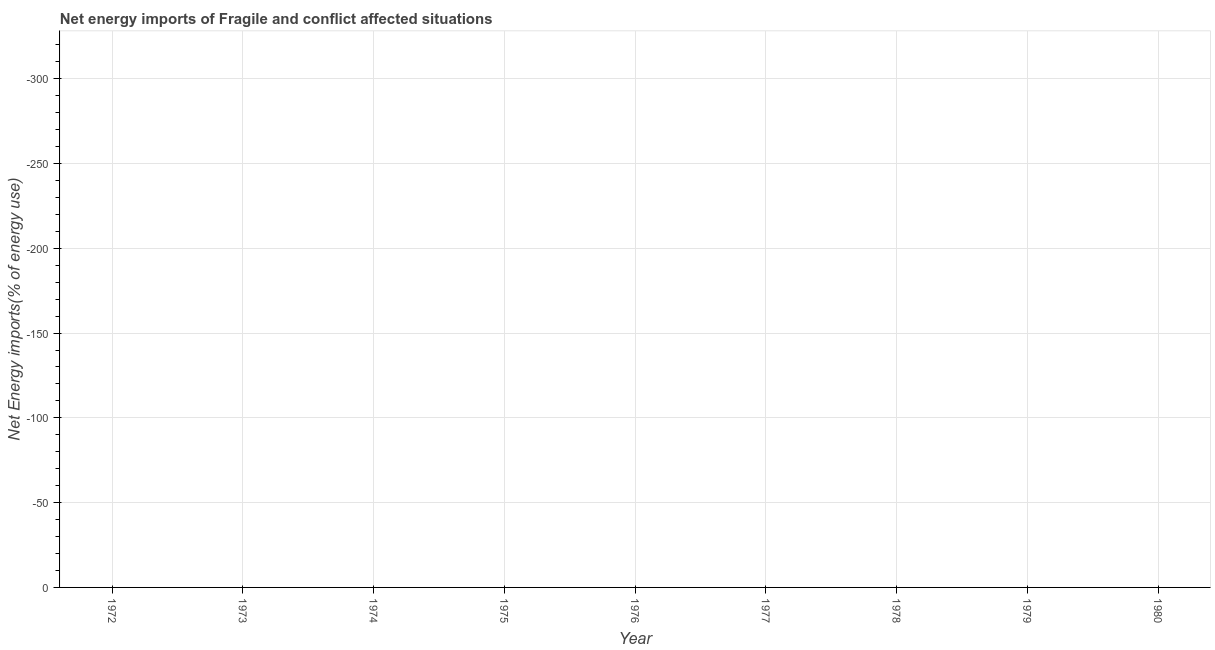Across all years, what is the minimum energy imports?
Offer a very short reply. 0. What is the sum of the energy imports?
Make the answer very short. 0. What is the median energy imports?
Offer a terse response. 0. In how many years, is the energy imports greater than -180 %?
Your answer should be compact. 0. In how many years, is the energy imports greater than the average energy imports taken over all years?
Your answer should be compact. 0. Does the graph contain any zero values?
Give a very brief answer. Yes. What is the title of the graph?
Ensure brevity in your answer.  Net energy imports of Fragile and conflict affected situations. What is the label or title of the Y-axis?
Ensure brevity in your answer.  Net Energy imports(% of energy use). What is the Net Energy imports(% of energy use) of 1974?
Make the answer very short. 0. What is the Net Energy imports(% of energy use) in 1980?
Provide a succinct answer. 0. 